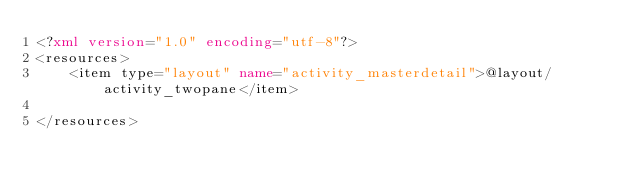<code> <loc_0><loc_0><loc_500><loc_500><_XML_><?xml version="1.0" encoding="utf-8"?>
<resources>
    <item type="layout" name="activity_masterdetail">@layout/activity_twopane</item>
    
</resources>
</code> 